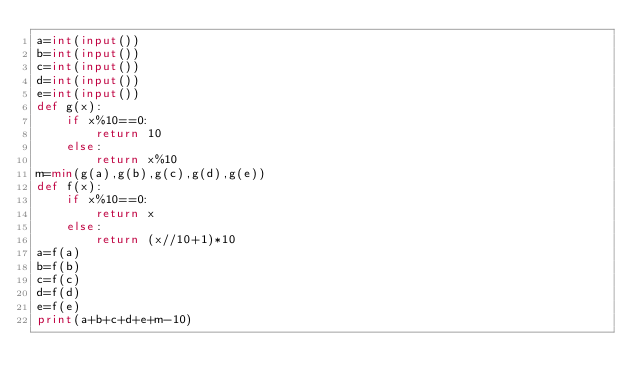Convert code to text. <code><loc_0><loc_0><loc_500><loc_500><_Python_>a=int(input())
b=int(input())
c=int(input())
d=int(input())
e=int(input())
def g(x):
    if x%10==0:
        return 10
    else:
        return x%10
m=min(g(a),g(b),g(c),g(d),g(e))
def f(x):
    if x%10==0:
        return x
    else:
        return (x//10+1)*10
a=f(a)
b=f(b)
c=f(c)
d=f(d)
e=f(e)
print(a+b+c+d+e+m-10)
</code> 